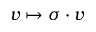Convert formula to latex. <formula><loc_0><loc_0><loc_500><loc_500>v \mapsto \sigma \cdot v</formula> 